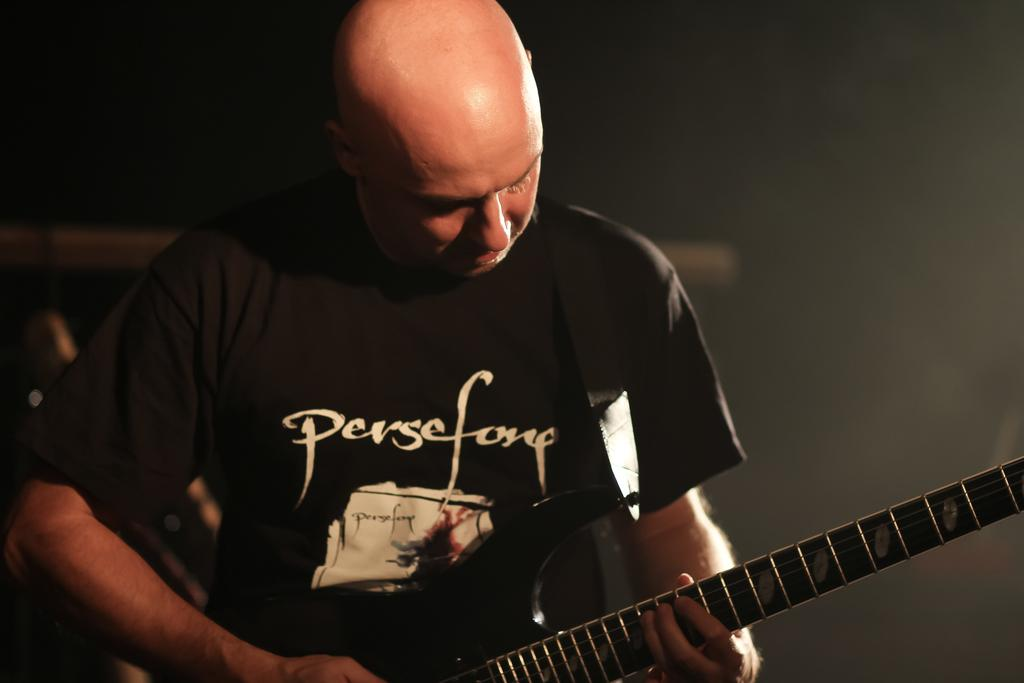Who is the person in the image? There is a man in the image. What is the man holding in the image? The man is holding a guitar. What is the man wearing in the image? The man is wearing a black shirt. What can be seen in the background of the image? There is a wall in the background of the image. What is the man's opinion on learning quietly in the image? The image does not provide any information about the man's opinion on learning quietly, as it only shows the man holding a guitar and wearing a black shirt. 